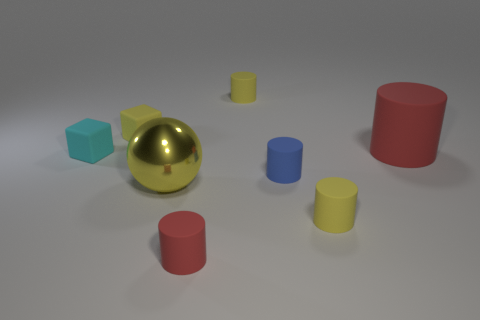Subtract all yellow cylinders. How many were subtracted if there are1yellow cylinders left? 1 Add 1 tiny brown things. How many objects exist? 9 Subtract all yellow matte cylinders. How many cylinders are left? 3 Subtract 2 blocks. How many blocks are left? 0 Subtract all cylinders. How many objects are left? 3 Add 1 small cyan things. How many small cyan things are left? 2 Add 7 shiny spheres. How many shiny spheres exist? 8 Subtract all red cylinders. How many cylinders are left? 3 Subtract 0 gray blocks. How many objects are left? 8 Subtract all red blocks. Subtract all gray spheres. How many blocks are left? 2 